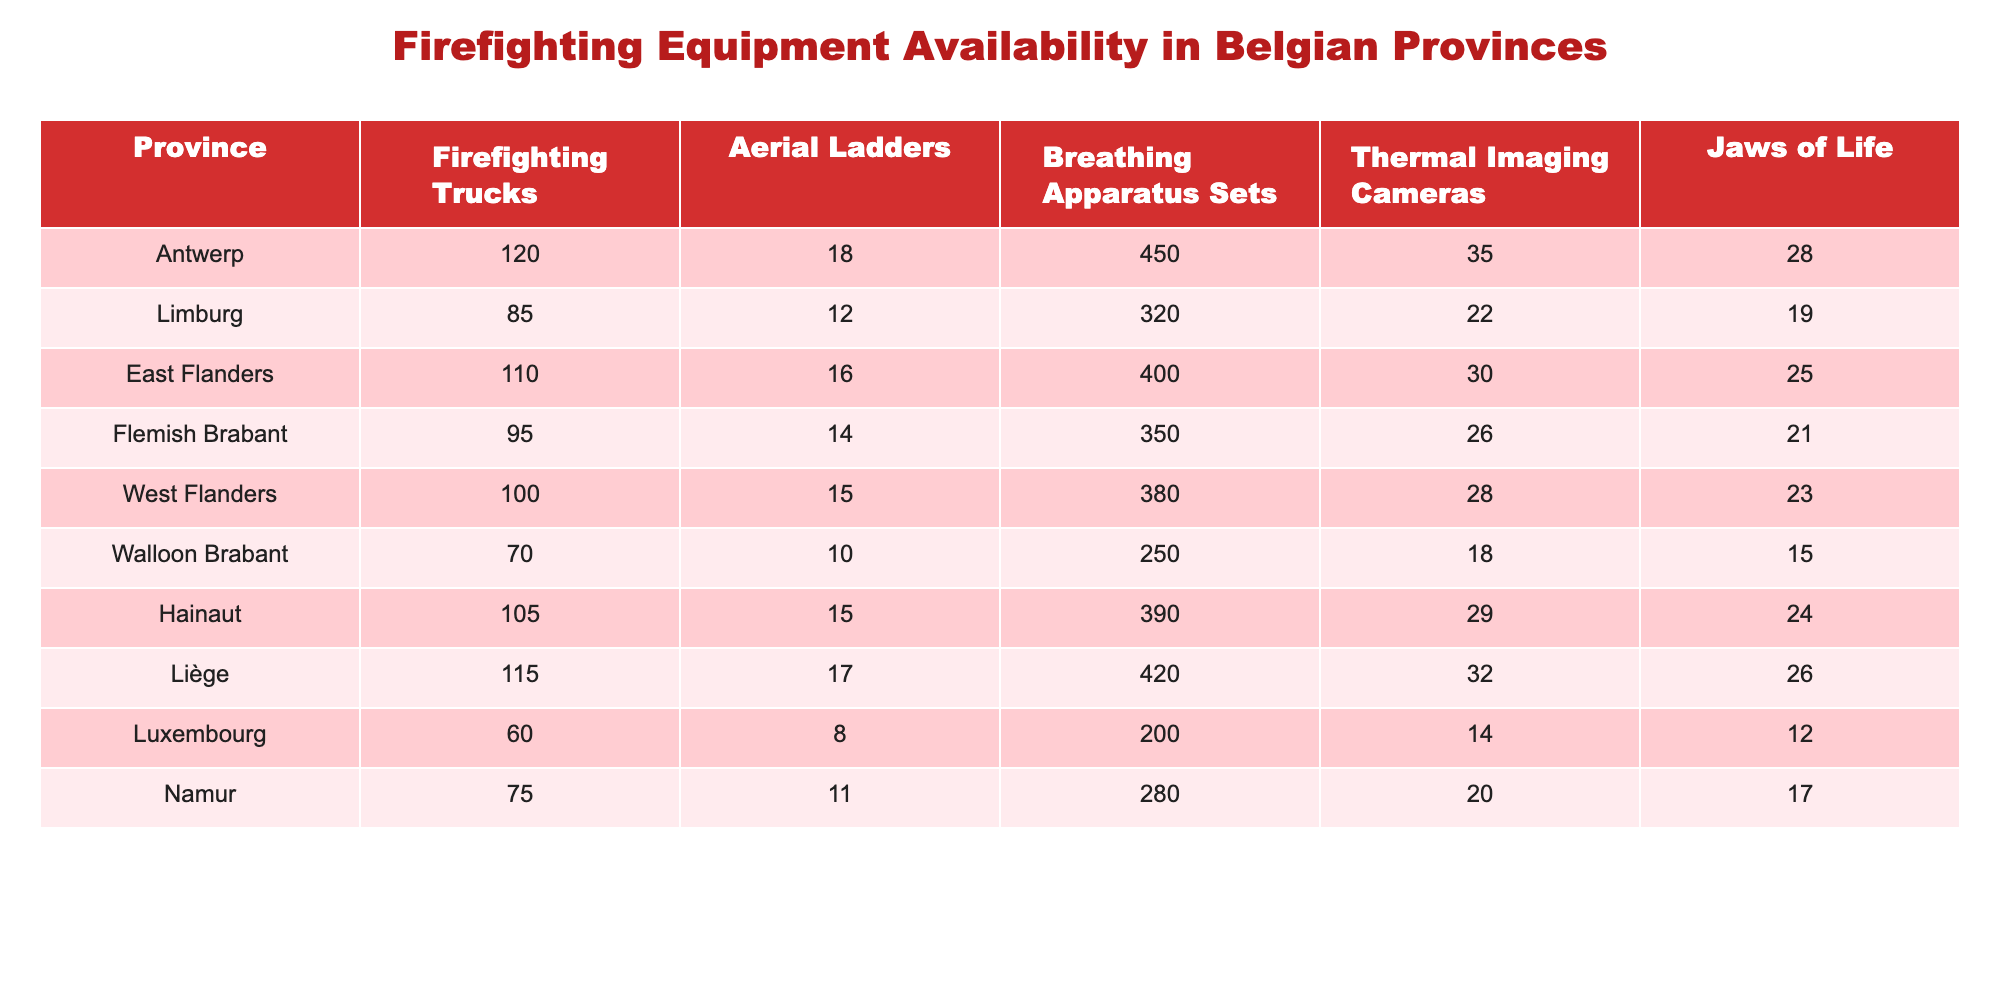What province has the highest number of firefighting trucks? By examining the column for firefighting trucks, we can see that Antwerp has the highest value at 120 trucks.
Answer: Antwerp How many aerial ladders does Hainaut have compared to West Flanders? Hainaut has 15 aerial ladders while West Flanders has 15 as well, so both provinces have the same number.
Answer: They have the same number What is the total number of breathing apparatus sets available in Namur and Walloon Brabant? For Namur, there are 280 breathing apparatus sets, and for Walloon Brabant, there are 250. Adding these together gives 280 + 250 = 530 sets.
Answer: 530 Which province has the least number of thermal imaging cameras? Looking at the thermal imaging cameras column, Luxembourg has the least with 14 cameras.
Answer: Luxembourg What is the average number of Jaws of Life across all provinces? We first sum the Jaws of Life across all provinces: 28 + 19 + 25 + 21 + 23 + 15 + 24 + 26 + 12 + 17 = 210. Since there are 10 provinces, we then divide by 10 to get the average: 210 / 10 = 21.
Answer: 21 Is it true that East Flanders has more breathing apparatus sets than Limburg? East Flanders has 400 breathing apparatus sets, while Limburg has 320. Since 400 is greater than 320, the statement is true.
Answer: True What is the difference in the number of aerial ladders between Antwerp and Liège? Antwerp has 18 aerial ladders and Liège has 17. The difference is 18 - 17 = 1.
Answer: 1 What province has the most total firefighting equipment (sum of all categories)? We calculate the total for each province: Antwerp (120+18+450+35+28=651), Limburg (85+12+320+22+19=458), East Flanders (110+16+400+30+25=581), Flemish Brabant (95+14+350+26+21=506), West Flanders (100+15+380+28+23=546), Walloon Brabant (70+10+250+18+15=363), Hainaut (105+15+390+29+24=563), Liège (115+17+420+32+26=610), Luxembourg (60+8+200+14+12=294), and Namur (75+11+280+20+17=413). The highest total is for Antwerp with 651.
Answer: Antwerp How many more breathing apparatus sets does Liège have compared to Walloon Brabant? Liège has 420 breathing apparatus sets while Walloon Brabant has 250. The difference is 420 - 250 = 170 sets.
Answer: 170 Which province has fewer than 200 thermal imaging cameras? Looking at the thermal imaging cameras column, we see that only Luxembourg has 14 which is fewer than 200.
Answer: Luxembourg 